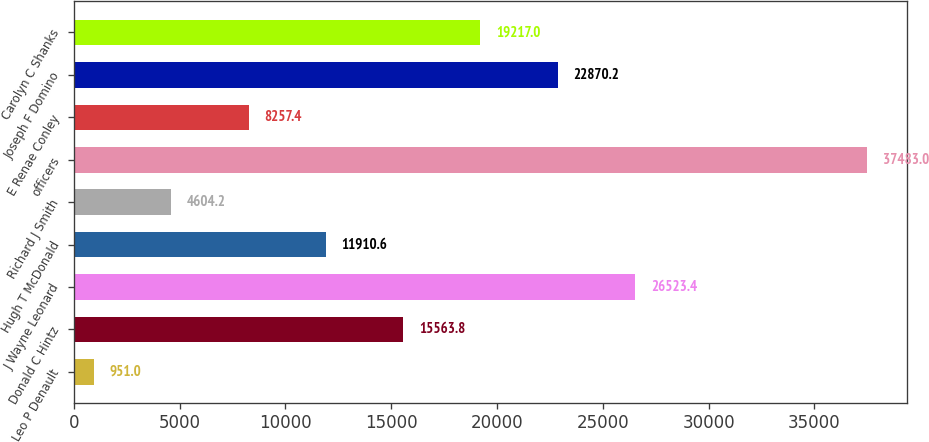<chart> <loc_0><loc_0><loc_500><loc_500><bar_chart><fcel>Leo P Denault<fcel>Donald C Hintz<fcel>J Wayne Leonard<fcel>Hugh T McDonald<fcel>Richard J Smith<fcel>officers<fcel>E Renae Conley<fcel>Joseph F Domino<fcel>Carolyn C Shanks<nl><fcel>951<fcel>15563.8<fcel>26523.4<fcel>11910.6<fcel>4604.2<fcel>37483<fcel>8257.4<fcel>22870.2<fcel>19217<nl></chart> 